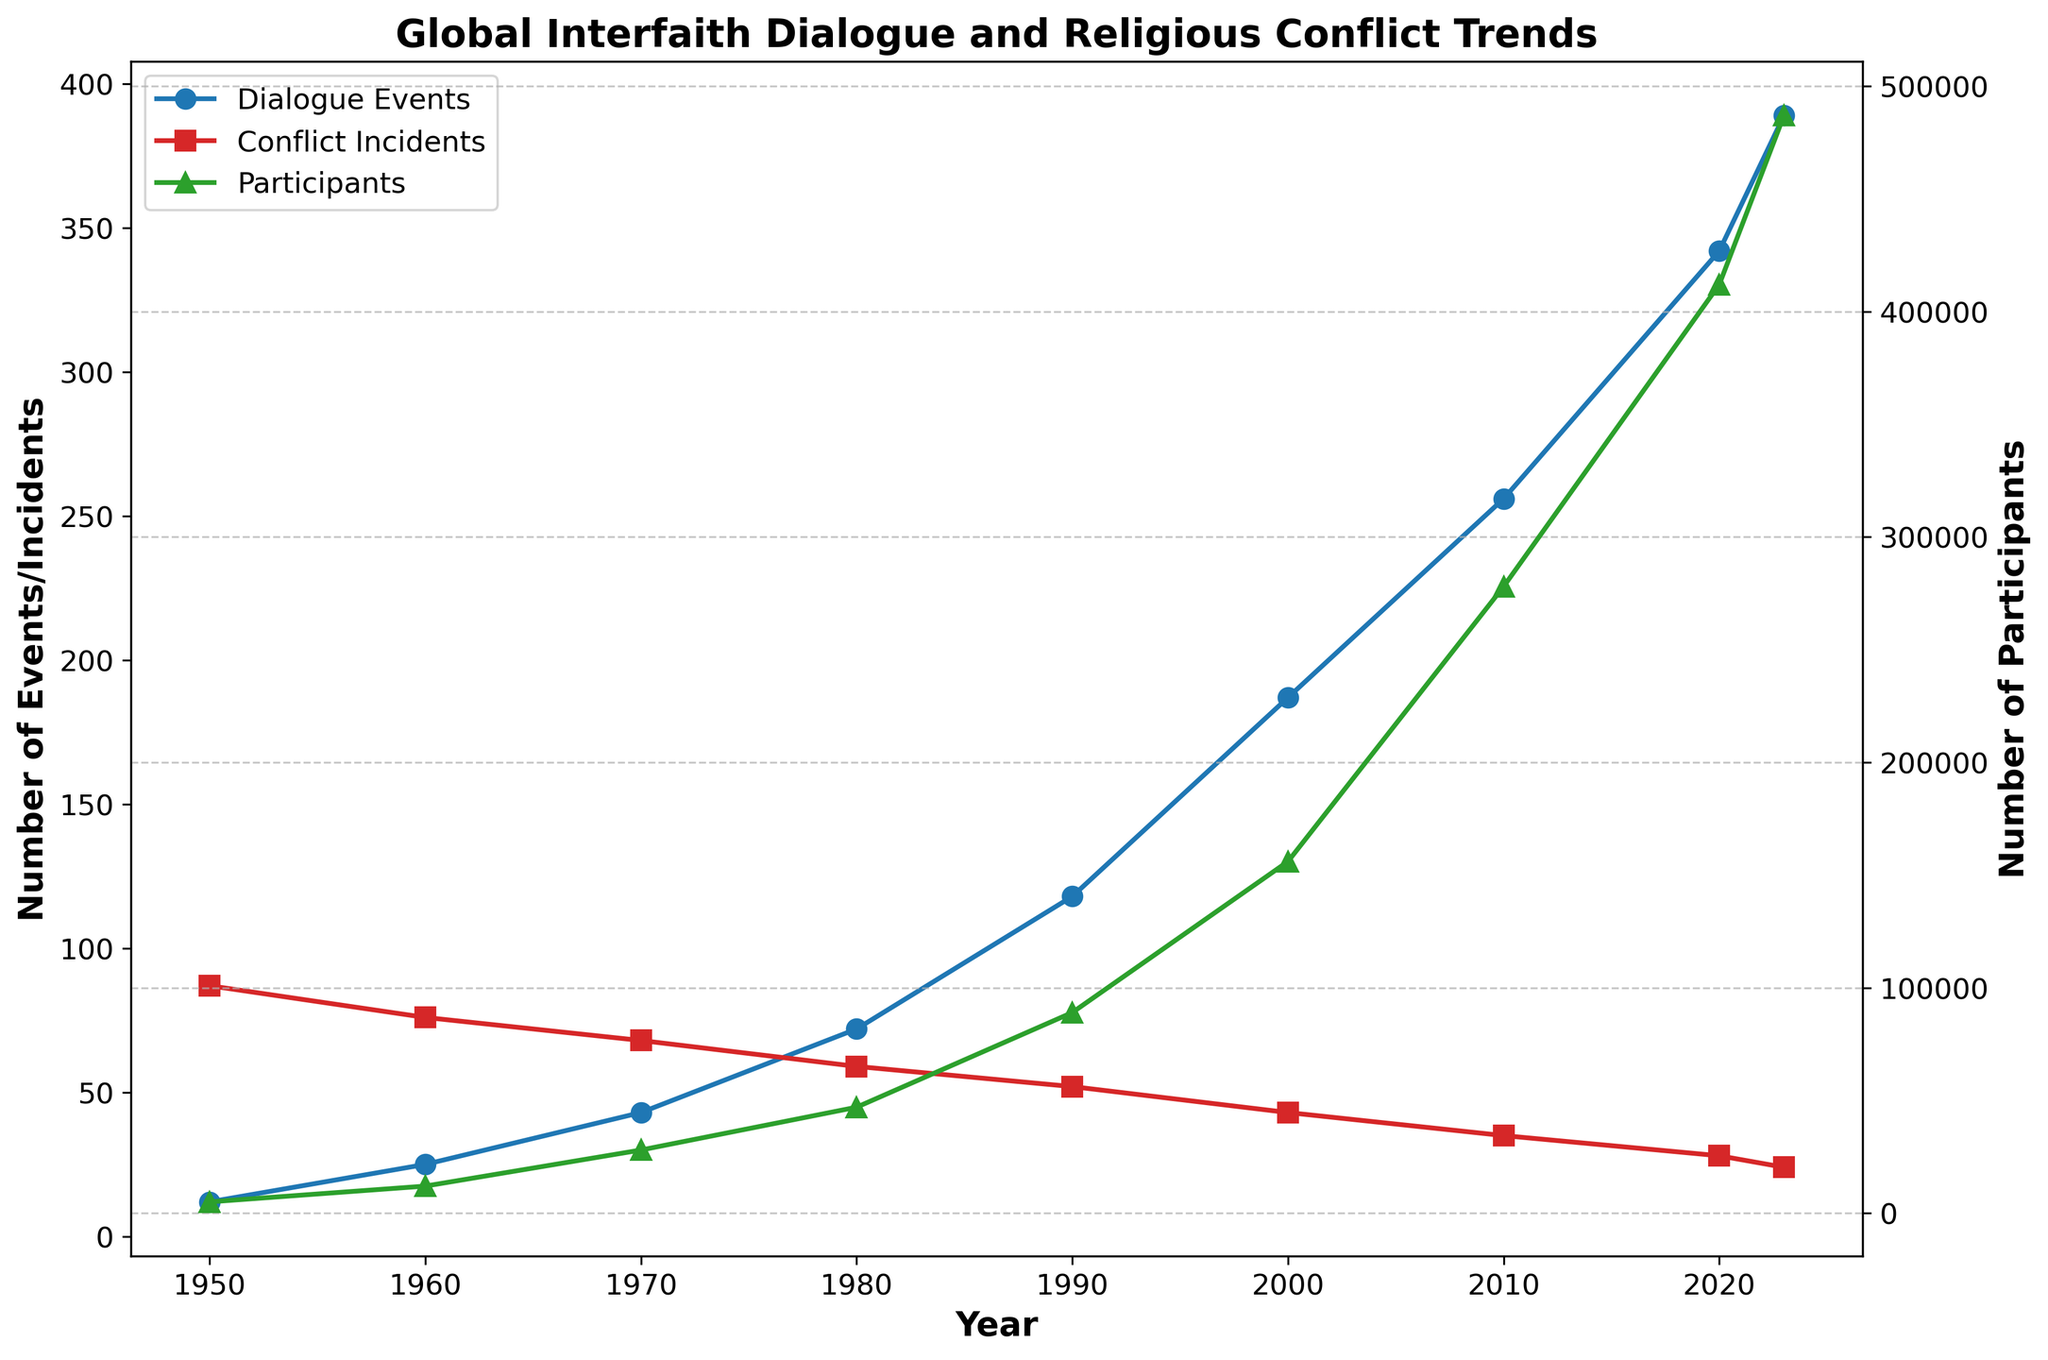What is the trend in the number of Global Interfaith Dialogue Events from 1950 to 2023? The number of Global Interfaith Dialogue Events has increased consistently from 12 in 1950 to 389 in 2023.
Answer: Increasing trend When did the number of Religious Conflict Incidents first drop below 50, and what was the corresponding count of Global Interfaith Dialogue Events that year? The number of Religious Conflict Incidents first dropped below 50 in 2000, with the count being 43. During that year, the number of Global Interfaith Dialogue Events was 187.
Answer: 2000; 187 How did the number of Participants in Interfaith Programs change between 1980 and 2020? In 1980, there were 47,000 participants, and this number increased to 412,000 by 2020. The change in participants was 412,000 - 47,000 = 365,000.
Answer: Increased by 365,000 Compare the numbers of Religious Conflict Incidents in 1960 and 2023. Which year had more incidents? In 1960, there were 76 Religious Conflict Incidents, whereas, in 2023, there were 24 incidents. Therefore, 1960 had more incidents.
Answer: 1960 What is the lowest number of Religious Conflict Incidents reported in the dataset, and in which year was it observed? The lowest number of Religious Conflict Incidents reported in the dataset is 24, observed in 2023.
Answer: 24 in 2023 Which year shows the highest number of Participants in Interfaith Programs, and how many participants were there? The highest number of Participants in Interfaith Programs was in 2023, with 487,000 participants.
Answer: 2023 with 487,000 participants How many new Interfaith Organizations were founded between the 1960s and the 2000s, and what is the total number of such organizations founded by 2020? Between 1960 and 2000, the number of new Interfaith Organizations founded increased from 5 to 37, giving us 32 new organizations. By 2020, a total of 68 organizations had been founded (considering the continuous growth).
Answer: 32 new organizations; total 68 by 2020 What pattern do you observe concerning the relationship between Global Interfaith Dialogue Events and Religious Conflict Incidents? As the number of Global Interfaith Dialogue Events increases, the number of Religious Conflict Incidents generally decreases over time, suggesting a potential relationship where more dialogue events might contribute to fewer conflicts.
Answer: Negative correlation In which decade did the number of Global Interfaith Dialogue Events see the most significant increase, and by how many events did it rise? The most significant increase occurred between 1980 and 1990, where events rose from 72 to 118, an increase of 46 events.
Answer: 1980 to 1990; 46 events 